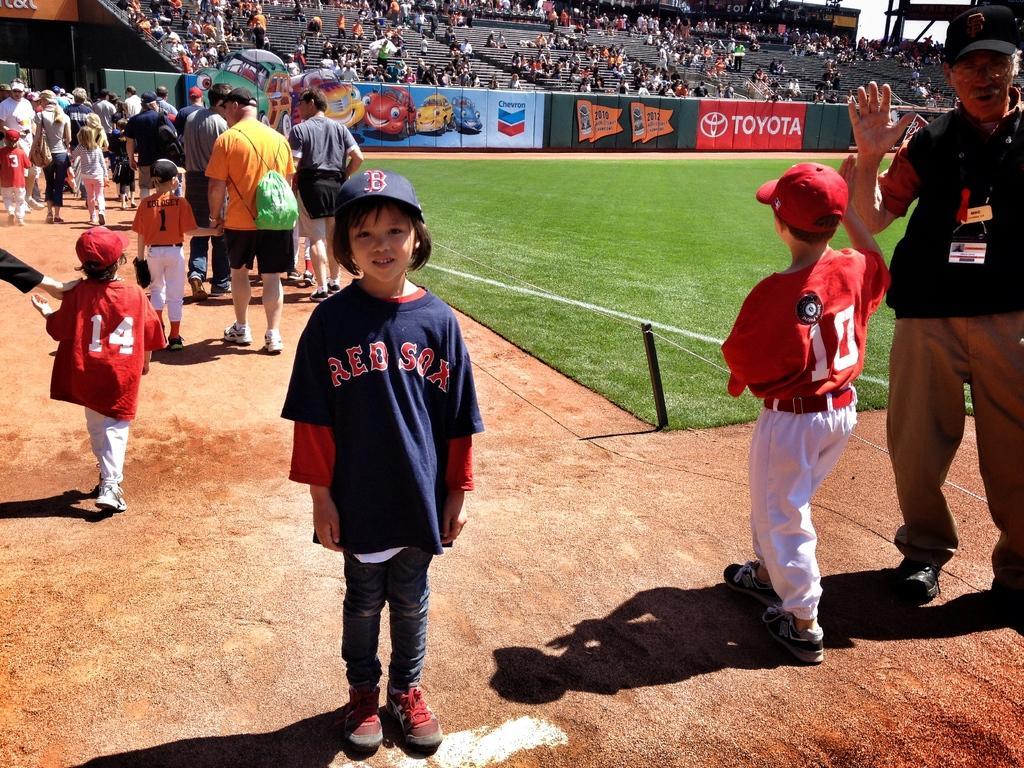Can you describe this image briefly? In this image, we can see persons and kids wearing clothes. There is a crowd and wall at the top of the image. 